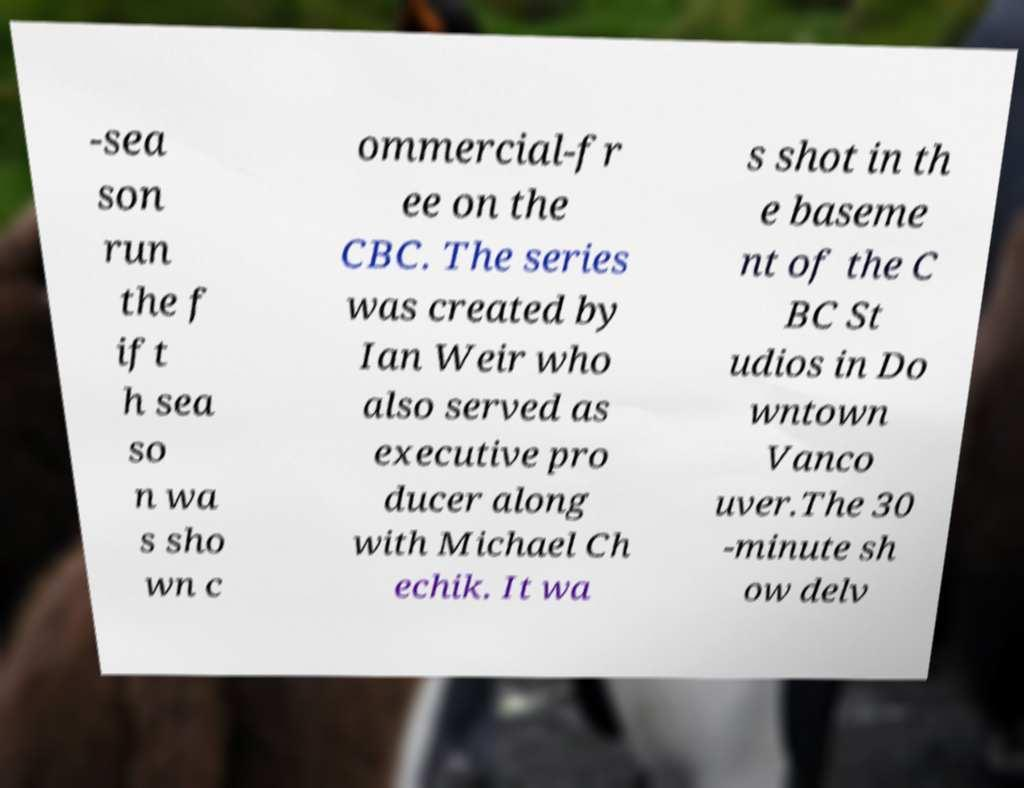For documentation purposes, I need the text within this image transcribed. Could you provide that? -sea son run the f ift h sea so n wa s sho wn c ommercial-fr ee on the CBC. The series was created by Ian Weir who also served as executive pro ducer along with Michael Ch echik. It wa s shot in th e baseme nt of the C BC St udios in Do wntown Vanco uver.The 30 -minute sh ow delv 